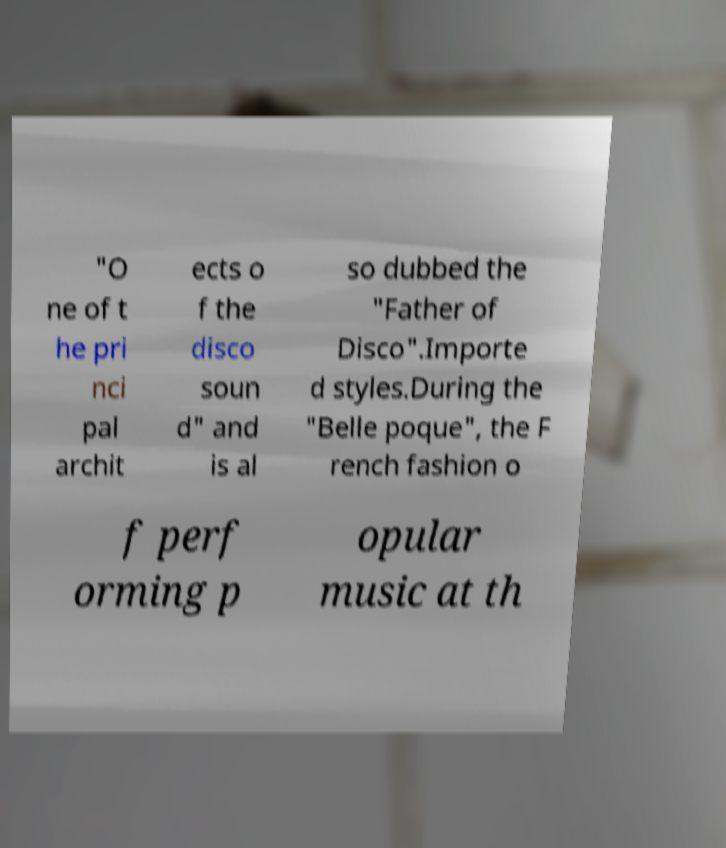Can you read and provide the text displayed in the image?This photo seems to have some interesting text. Can you extract and type it out for me? "O ne of t he pri nci pal archit ects o f the disco soun d" and is al so dubbed the "Father of Disco".Importe d styles.During the "Belle poque", the F rench fashion o f perf orming p opular music at th 